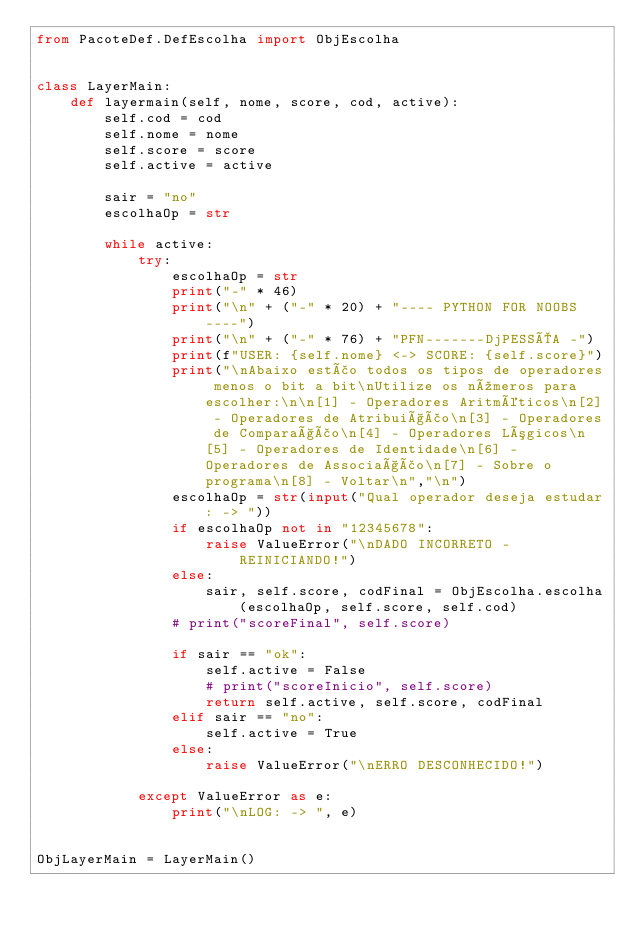<code> <loc_0><loc_0><loc_500><loc_500><_Python_>from PacoteDef.DefEscolha import ObjEscolha


class LayerMain:
    def layermain(self, nome, score, cod, active):
        self.cod = cod
        self.nome = nome
        self.score = score
        self.active = active

        sair = "no"
        escolhaOp = str

        while active:
            try:
                escolhaOp = str
                print("-" * 46)
                print("\n" + ("-" * 20) + "---- PYTHON FOR NOOBS ----")
                print("\n" + ("-" * 76) + "PFN-------DjPESSÔA -")             
                print(f"USER: {self.nome} <-> SCORE: {self.score}")
                print("\nAbaixo estão todos os tipos de operadores menos o bit a bit\nUtilize os números para escolher:\n\n[1] - Operadores Aritméticos\n[2] - Operadores de Atribuição\n[3] - Operadores de Comparação\n[4] - Operadores Lógicos\n[5] - Operadores de Identidade\n[6] - Operadores de Associação\n[7] - Sobre o programa\n[8] - Voltar\n","\n")
                escolhaOp = str(input("Qual operador deseja estudar: -> "))
                if escolhaOp not in "12345678":
                    raise ValueError("\nDADO INCORRETO - REINICIANDO!")
                else:
                    sair, self.score, codFinal = ObjEscolha.escolha(escolhaOp, self.score, self.cod)
                # print("scoreFinal", self.score)

                if sair == "ok":
                    self.active = False
                    # print("scoreInicio", self.score)
                    return self.active, self.score, codFinal
                elif sair == "no":
                    self.active = True
                else:
                    raise ValueError("\nERRO DESCONHECIDO!")

            except ValueError as e:
                print("\nLOG: -> ", e)


ObjLayerMain = LayerMain()
</code> 